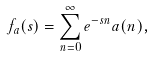Convert formula to latex. <formula><loc_0><loc_0><loc_500><loc_500>f _ { a } ( s ) = \sum _ { n = 0 } ^ { \infty } e ^ { - s n } a ( n ) ,</formula> 